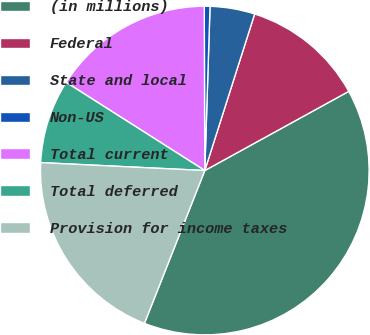Convert chart to OTSL. <chart><loc_0><loc_0><loc_500><loc_500><pie_chart><fcel>(in millions)<fcel>Federal<fcel>State and local<fcel>Non-US<fcel>Total current<fcel>Total deferred<fcel>Provision for income taxes<nl><fcel>38.99%<fcel>12.09%<fcel>4.4%<fcel>0.56%<fcel>15.93%<fcel>8.25%<fcel>19.78%<nl></chart> 